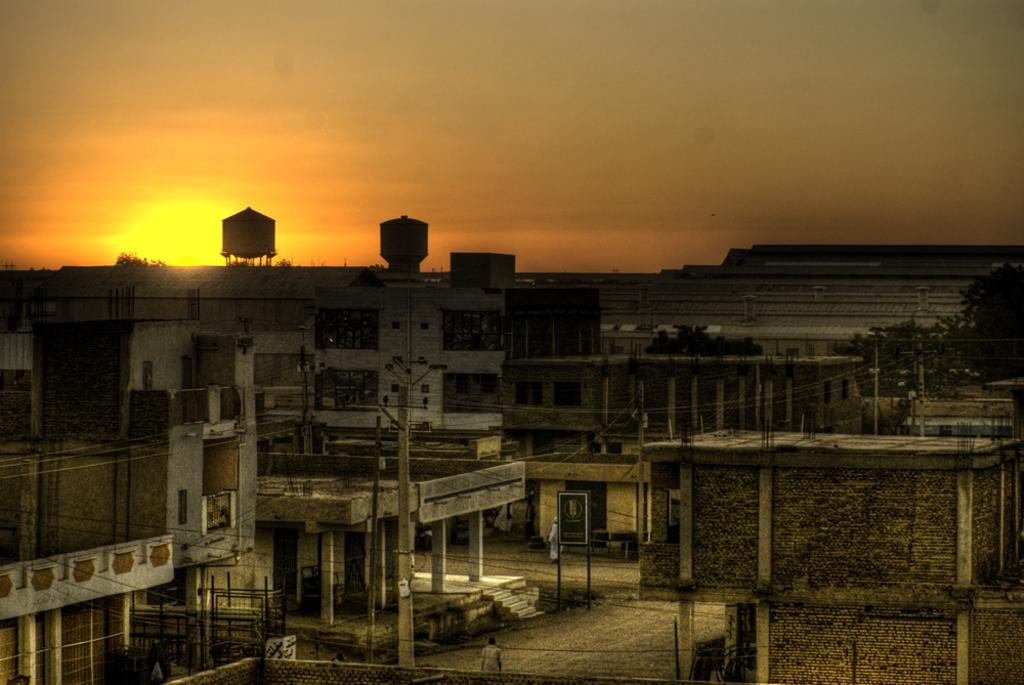Who or what can be seen in the image? There are people in the image. What structures are visible in the image? There are buildings in the image. What utility infrastructure is present in the image? Current poles and wires are visible in the image. What additional feature can be seen on a pole in the image? There is a board on a pole in the image. What natural elements can be seen in the background of the image? There are trees and the sky visible in the background of the image. Can you tell me how many goldfish are swimming in the image? There are no goldfish present in the image. What type of grape is being used to decorate the board on the pole? There is no grape present in the image, and the board on the pole does not appear to be decorated with any fruit. 